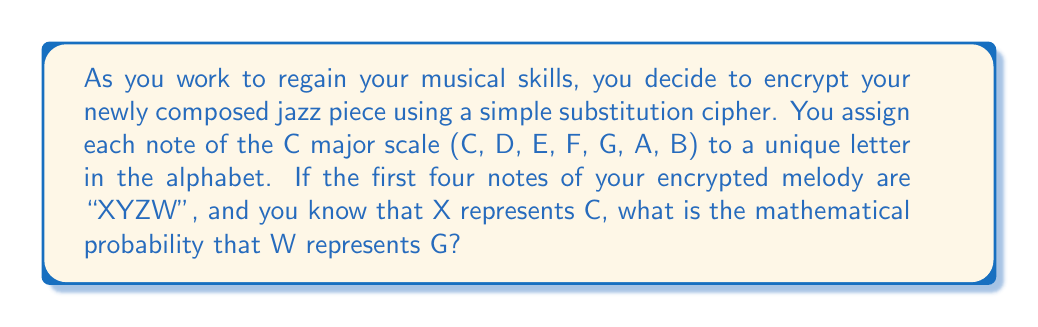Help me with this question. Let's approach this step-by-step:

1) First, we need to understand the given information:
   - We're using a simple substitution cipher
   - We're working with the C major scale: C, D, E, F, G, A, B
   - The encrypted sequence is XYZW
   - X represents C

2) Now, let's consider the possible assignments:
   - X → C (given)
   - Y → could be D, E, F, G, A, or B (6 possibilities)
   - Z → could be any of the remaining 5 notes
   - W → could be any of the remaining 4 notes

3) To calculate the probability that W represents G, we need to consider two scenarios:
   a) G was not assigned to Y or Z
   b) G was assigned to Y or Z

4) Let's calculate the probability of scenario a):
   - Probability of G not being Y: $\frac{5}{6}$
   - Probability of G not being Z, given it's not Y: $\frac{4}{5}$
   - Probability of W being G, given it's not Y or Z: $\frac{1}{4}$

   $$P(W=G | G \neq Y \text{ and } G \neq Z) = \frac{5}{6} \cdot \frac{4}{5} \cdot \frac{1}{4} = \frac{1}{6}$$

5) The probability of scenario b) is 0, as if G was assigned to Y or Z, it cannot be assigned to W.

6) Therefore, the total probability is just the probability of scenario a):

   $$P(W=G) = \frac{1}{6}$$
Answer: $\frac{1}{6}$ 